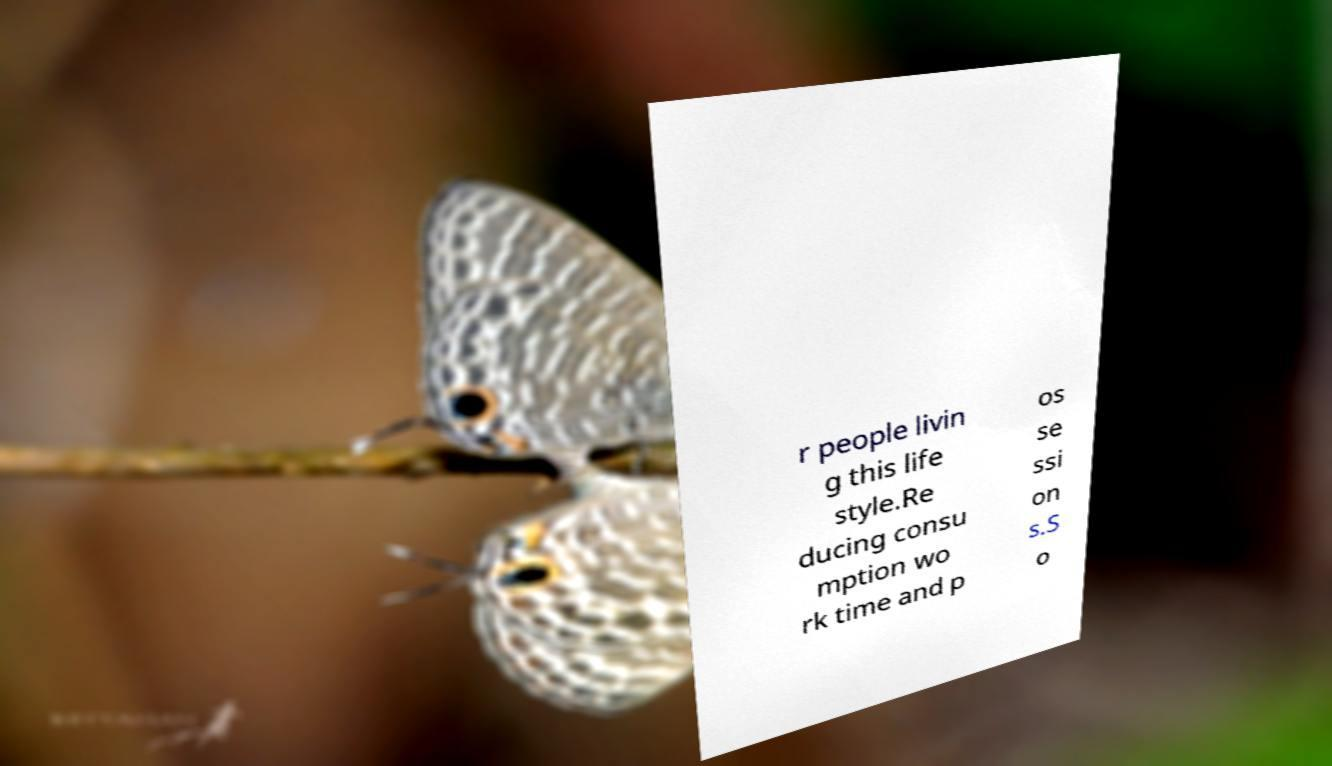Can you read and provide the text displayed in the image?This photo seems to have some interesting text. Can you extract and type it out for me? r people livin g this life style.Re ducing consu mption wo rk time and p os se ssi on s.S o 